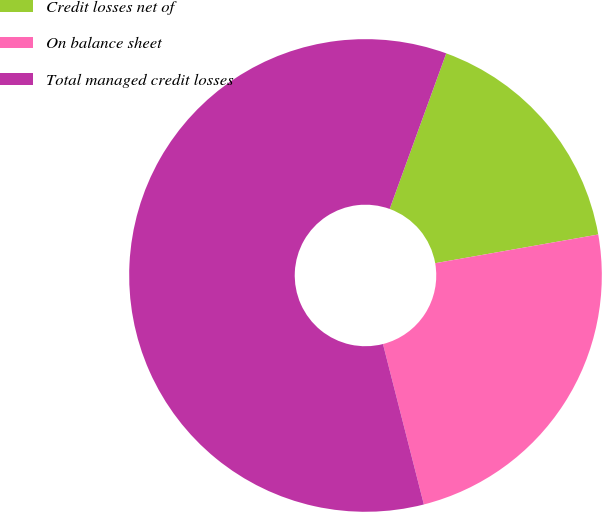Convert chart to OTSL. <chart><loc_0><loc_0><loc_500><loc_500><pie_chart><fcel>Credit losses net of<fcel>On balance sheet<fcel>Total managed credit losses<nl><fcel>16.68%<fcel>23.8%<fcel>59.52%<nl></chart> 